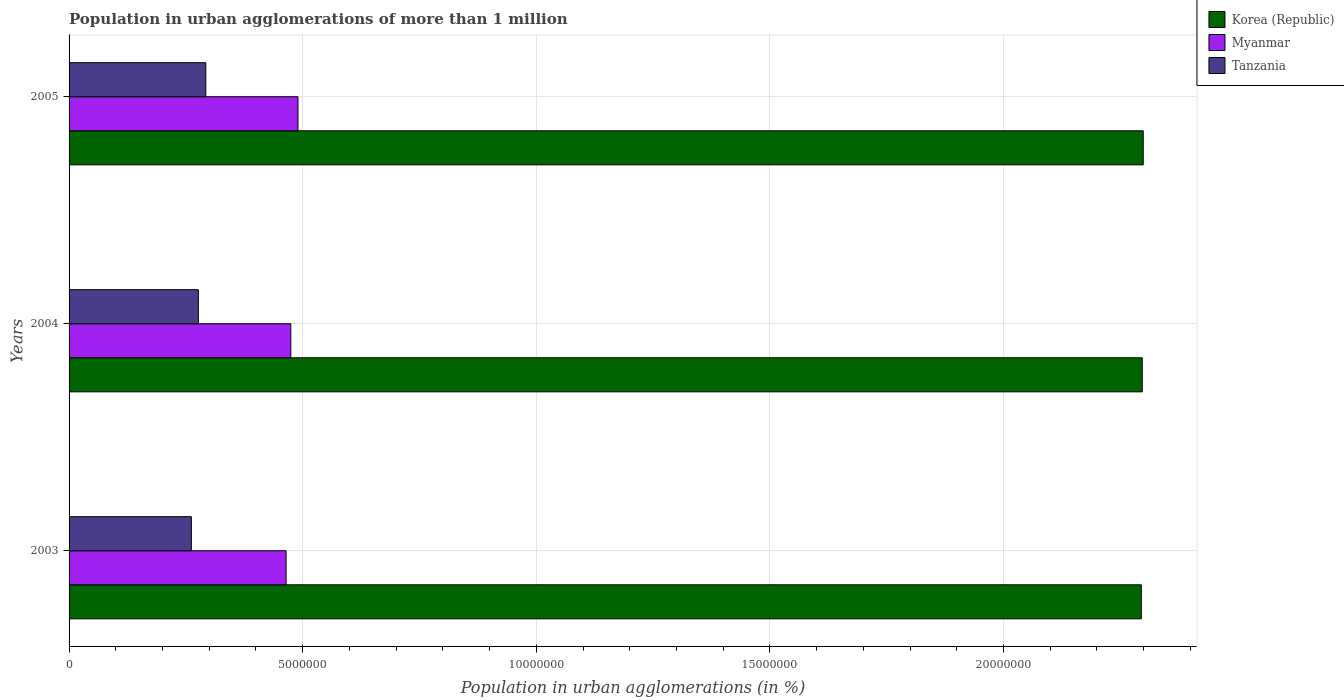How many different coloured bars are there?
Your response must be concise. 3. How many groups of bars are there?
Your response must be concise. 3. Are the number of bars on each tick of the Y-axis equal?
Provide a succinct answer. Yes. How many bars are there on the 1st tick from the bottom?
Your response must be concise. 3. What is the population in urban agglomerations in Korea (Republic) in 2005?
Make the answer very short. 2.30e+07. Across all years, what is the maximum population in urban agglomerations in Korea (Republic)?
Make the answer very short. 2.30e+07. Across all years, what is the minimum population in urban agglomerations in Myanmar?
Offer a very short reply. 4.64e+06. In which year was the population in urban agglomerations in Tanzania minimum?
Your response must be concise. 2003. What is the total population in urban agglomerations in Tanzania in the graph?
Offer a very short reply. 8.31e+06. What is the difference between the population in urban agglomerations in Tanzania in 2004 and that in 2005?
Ensure brevity in your answer.  -1.59e+05. What is the difference between the population in urban agglomerations in Myanmar in 2005 and the population in urban agglomerations in Tanzania in 2003?
Your answer should be compact. 2.28e+06. What is the average population in urban agglomerations in Korea (Republic) per year?
Give a very brief answer. 2.30e+07. In the year 2004, what is the difference between the population in urban agglomerations in Korea (Republic) and population in urban agglomerations in Myanmar?
Provide a short and direct response. 1.82e+07. In how many years, is the population in urban agglomerations in Myanmar greater than 11000000 %?
Give a very brief answer. 0. What is the ratio of the population in urban agglomerations in Korea (Republic) in 2003 to that in 2004?
Keep it short and to the point. 1. What is the difference between the highest and the second highest population in urban agglomerations in Myanmar?
Your answer should be compact. 1.53e+05. What is the difference between the highest and the lowest population in urban agglomerations in Myanmar?
Your response must be concise. 2.54e+05. Is the sum of the population in urban agglomerations in Tanzania in 2004 and 2005 greater than the maximum population in urban agglomerations in Korea (Republic) across all years?
Your answer should be compact. No. Are all the bars in the graph horizontal?
Provide a short and direct response. Yes. What is the difference between two consecutive major ticks on the X-axis?
Provide a short and direct response. 5.00e+06. Does the graph contain any zero values?
Offer a terse response. No. Where does the legend appear in the graph?
Your answer should be compact. Top right. How many legend labels are there?
Provide a succinct answer. 3. How are the legend labels stacked?
Ensure brevity in your answer.  Vertical. What is the title of the graph?
Make the answer very short. Population in urban agglomerations of more than 1 million. What is the label or title of the X-axis?
Offer a terse response. Population in urban agglomerations (in %). What is the label or title of the Y-axis?
Your answer should be very brief. Years. What is the Population in urban agglomerations (in %) of Korea (Republic) in 2003?
Give a very brief answer. 2.29e+07. What is the Population in urban agglomerations (in %) of Myanmar in 2003?
Your response must be concise. 4.64e+06. What is the Population in urban agglomerations (in %) of Tanzania in 2003?
Your answer should be compact. 2.62e+06. What is the Population in urban agglomerations (in %) of Korea (Republic) in 2004?
Your answer should be very brief. 2.30e+07. What is the Population in urban agglomerations (in %) in Myanmar in 2004?
Keep it short and to the point. 4.75e+06. What is the Population in urban agglomerations (in %) in Tanzania in 2004?
Keep it short and to the point. 2.77e+06. What is the Population in urban agglomerations (in %) of Korea (Republic) in 2005?
Provide a short and direct response. 2.30e+07. What is the Population in urban agglomerations (in %) of Myanmar in 2005?
Ensure brevity in your answer.  4.90e+06. What is the Population in urban agglomerations (in %) in Tanzania in 2005?
Offer a very short reply. 2.93e+06. Across all years, what is the maximum Population in urban agglomerations (in %) in Korea (Republic)?
Your response must be concise. 2.30e+07. Across all years, what is the maximum Population in urban agglomerations (in %) of Myanmar?
Ensure brevity in your answer.  4.90e+06. Across all years, what is the maximum Population in urban agglomerations (in %) of Tanzania?
Provide a succinct answer. 2.93e+06. Across all years, what is the minimum Population in urban agglomerations (in %) of Korea (Republic)?
Keep it short and to the point. 2.29e+07. Across all years, what is the minimum Population in urban agglomerations (in %) in Myanmar?
Keep it short and to the point. 4.64e+06. Across all years, what is the minimum Population in urban agglomerations (in %) in Tanzania?
Keep it short and to the point. 2.62e+06. What is the total Population in urban agglomerations (in %) of Korea (Republic) in the graph?
Provide a short and direct response. 6.89e+07. What is the total Population in urban agglomerations (in %) of Myanmar in the graph?
Provide a succinct answer. 1.43e+07. What is the total Population in urban agglomerations (in %) of Tanzania in the graph?
Ensure brevity in your answer.  8.31e+06. What is the difference between the Population in urban agglomerations (in %) in Korea (Republic) in 2003 and that in 2004?
Give a very brief answer. -2.00e+04. What is the difference between the Population in urban agglomerations (in %) of Myanmar in 2003 and that in 2004?
Make the answer very short. -1.01e+05. What is the difference between the Population in urban agglomerations (in %) in Tanzania in 2003 and that in 2004?
Keep it short and to the point. -1.51e+05. What is the difference between the Population in urban agglomerations (in %) of Korea (Republic) in 2003 and that in 2005?
Keep it short and to the point. -4.10e+04. What is the difference between the Population in urban agglomerations (in %) in Myanmar in 2003 and that in 2005?
Offer a very short reply. -2.54e+05. What is the difference between the Population in urban agglomerations (in %) in Tanzania in 2003 and that in 2005?
Offer a terse response. -3.09e+05. What is the difference between the Population in urban agglomerations (in %) in Korea (Republic) in 2004 and that in 2005?
Offer a terse response. -2.10e+04. What is the difference between the Population in urban agglomerations (in %) in Myanmar in 2004 and that in 2005?
Make the answer very short. -1.53e+05. What is the difference between the Population in urban agglomerations (in %) of Tanzania in 2004 and that in 2005?
Your response must be concise. -1.59e+05. What is the difference between the Population in urban agglomerations (in %) of Korea (Republic) in 2003 and the Population in urban agglomerations (in %) of Myanmar in 2004?
Offer a terse response. 1.82e+07. What is the difference between the Population in urban agglomerations (in %) of Korea (Republic) in 2003 and the Population in urban agglomerations (in %) of Tanzania in 2004?
Keep it short and to the point. 2.02e+07. What is the difference between the Population in urban agglomerations (in %) of Myanmar in 2003 and the Population in urban agglomerations (in %) of Tanzania in 2004?
Keep it short and to the point. 1.88e+06. What is the difference between the Population in urban agglomerations (in %) of Korea (Republic) in 2003 and the Population in urban agglomerations (in %) of Myanmar in 2005?
Provide a short and direct response. 1.81e+07. What is the difference between the Population in urban agglomerations (in %) in Korea (Republic) in 2003 and the Population in urban agglomerations (in %) in Tanzania in 2005?
Your answer should be compact. 2.00e+07. What is the difference between the Population in urban agglomerations (in %) of Myanmar in 2003 and the Population in urban agglomerations (in %) of Tanzania in 2005?
Provide a succinct answer. 1.72e+06. What is the difference between the Population in urban agglomerations (in %) in Korea (Republic) in 2004 and the Population in urban agglomerations (in %) in Myanmar in 2005?
Keep it short and to the point. 1.81e+07. What is the difference between the Population in urban agglomerations (in %) of Korea (Republic) in 2004 and the Population in urban agglomerations (in %) of Tanzania in 2005?
Ensure brevity in your answer.  2.00e+07. What is the difference between the Population in urban agglomerations (in %) of Myanmar in 2004 and the Population in urban agglomerations (in %) of Tanzania in 2005?
Provide a succinct answer. 1.82e+06. What is the average Population in urban agglomerations (in %) of Korea (Republic) per year?
Keep it short and to the point. 2.30e+07. What is the average Population in urban agglomerations (in %) in Myanmar per year?
Your answer should be very brief. 4.76e+06. What is the average Population in urban agglomerations (in %) of Tanzania per year?
Your answer should be compact. 2.77e+06. In the year 2003, what is the difference between the Population in urban agglomerations (in %) of Korea (Republic) and Population in urban agglomerations (in %) of Myanmar?
Your answer should be very brief. 1.83e+07. In the year 2003, what is the difference between the Population in urban agglomerations (in %) of Korea (Republic) and Population in urban agglomerations (in %) of Tanzania?
Make the answer very short. 2.03e+07. In the year 2003, what is the difference between the Population in urban agglomerations (in %) of Myanmar and Population in urban agglomerations (in %) of Tanzania?
Give a very brief answer. 2.03e+06. In the year 2004, what is the difference between the Population in urban agglomerations (in %) in Korea (Republic) and Population in urban agglomerations (in %) in Myanmar?
Offer a very short reply. 1.82e+07. In the year 2004, what is the difference between the Population in urban agglomerations (in %) of Korea (Republic) and Population in urban agglomerations (in %) of Tanzania?
Your response must be concise. 2.02e+07. In the year 2004, what is the difference between the Population in urban agglomerations (in %) in Myanmar and Population in urban agglomerations (in %) in Tanzania?
Make the answer very short. 1.98e+06. In the year 2005, what is the difference between the Population in urban agglomerations (in %) of Korea (Republic) and Population in urban agglomerations (in %) of Myanmar?
Your answer should be compact. 1.81e+07. In the year 2005, what is the difference between the Population in urban agglomerations (in %) of Korea (Republic) and Population in urban agglomerations (in %) of Tanzania?
Ensure brevity in your answer.  2.01e+07. In the year 2005, what is the difference between the Population in urban agglomerations (in %) of Myanmar and Population in urban agglomerations (in %) of Tanzania?
Give a very brief answer. 1.97e+06. What is the ratio of the Population in urban agglomerations (in %) in Korea (Republic) in 2003 to that in 2004?
Your response must be concise. 1. What is the ratio of the Population in urban agglomerations (in %) in Myanmar in 2003 to that in 2004?
Give a very brief answer. 0.98. What is the ratio of the Population in urban agglomerations (in %) of Tanzania in 2003 to that in 2004?
Offer a terse response. 0.95. What is the ratio of the Population in urban agglomerations (in %) of Myanmar in 2003 to that in 2005?
Provide a succinct answer. 0.95. What is the ratio of the Population in urban agglomerations (in %) of Tanzania in 2003 to that in 2005?
Your answer should be very brief. 0.89. What is the ratio of the Population in urban agglomerations (in %) of Myanmar in 2004 to that in 2005?
Offer a terse response. 0.97. What is the ratio of the Population in urban agglomerations (in %) in Tanzania in 2004 to that in 2005?
Provide a succinct answer. 0.95. What is the difference between the highest and the second highest Population in urban agglomerations (in %) in Korea (Republic)?
Your answer should be compact. 2.10e+04. What is the difference between the highest and the second highest Population in urban agglomerations (in %) of Myanmar?
Provide a succinct answer. 1.53e+05. What is the difference between the highest and the second highest Population in urban agglomerations (in %) of Tanzania?
Ensure brevity in your answer.  1.59e+05. What is the difference between the highest and the lowest Population in urban agglomerations (in %) of Korea (Republic)?
Your answer should be compact. 4.10e+04. What is the difference between the highest and the lowest Population in urban agglomerations (in %) of Myanmar?
Provide a short and direct response. 2.54e+05. What is the difference between the highest and the lowest Population in urban agglomerations (in %) in Tanzania?
Your answer should be very brief. 3.09e+05. 